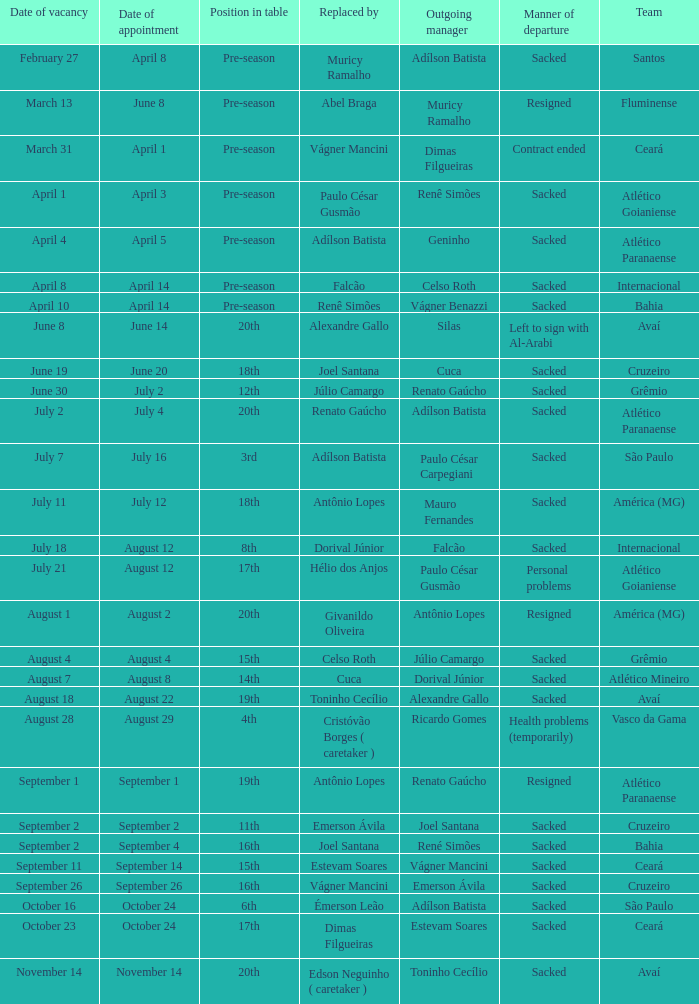Write the full table. {'header': ['Date of vacancy', 'Date of appointment', 'Position in table', 'Replaced by', 'Outgoing manager', 'Manner of departure', 'Team'], 'rows': [['February 27', 'April 8', 'Pre-season', 'Muricy Ramalho', 'Adílson Batista', 'Sacked', 'Santos'], ['March 13', 'June 8', 'Pre-season', 'Abel Braga', 'Muricy Ramalho', 'Resigned', 'Fluminense'], ['March 31', 'April 1', 'Pre-season', 'Vágner Mancini', 'Dimas Filgueiras', 'Contract ended', 'Ceará'], ['April 1', 'April 3', 'Pre-season', 'Paulo César Gusmão', 'Renê Simões', 'Sacked', 'Atlético Goianiense'], ['April 4', 'April 5', 'Pre-season', 'Adílson Batista', 'Geninho', 'Sacked', 'Atlético Paranaense'], ['April 8', 'April 14', 'Pre-season', 'Falcão', 'Celso Roth', 'Sacked', 'Internacional'], ['April 10', 'April 14', 'Pre-season', 'Renê Simões', 'Vágner Benazzi', 'Sacked', 'Bahia'], ['June 8', 'June 14', '20th', 'Alexandre Gallo', 'Silas', 'Left to sign with Al-Arabi', 'Avaí'], ['June 19', 'June 20', '18th', 'Joel Santana', 'Cuca', 'Sacked', 'Cruzeiro'], ['June 30', 'July 2', '12th', 'Júlio Camargo', 'Renato Gaúcho', 'Sacked', 'Grêmio'], ['July 2', 'July 4', '20th', 'Renato Gaúcho', 'Adílson Batista', 'Sacked', 'Atlético Paranaense'], ['July 7', 'July 16', '3rd', 'Adílson Batista', 'Paulo César Carpegiani', 'Sacked', 'São Paulo'], ['July 11', 'July 12', '18th', 'Antônio Lopes', 'Mauro Fernandes', 'Sacked', 'América (MG)'], ['July 18', 'August 12', '8th', 'Dorival Júnior', 'Falcão', 'Sacked', 'Internacional'], ['July 21', 'August 12', '17th', 'Hélio dos Anjos', 'Paulo César Gusmão', 'Personal problems', 'Atlético Goianiense'], ['August 1', 'August 2', '20th', 'Givanildo Oliveira', 'Antônio Lopes', 'Resigned', 'América (MG)'], ['August 4', 'August 4', '15th', 'Celso Roth', 'Júlio Camargo', 'Sacked', 'Grêmio'], ['August 7', 'August 8', '14th', 'Cuca', 'Dorival Júnior', 'Sacked', 'Atlético Mineiro'], ['August 18', 'August 22', '19th', 'Toninho Cecílio', 'Alexandre Gallo', 'Sacked', 'Avaí'], ['August 28', 'August 29', '4th', 'Cristóvão Borges ( caretaker )', 'Ricardo Gomes', 'Health problems (temporarily)', 'Vasco da Gama'], ['September 1', 'September 1', '19th', 'Antônio Lopes', 'Renato Gaúcho', 'Resigned', 'Atlético Paranaense'], ['September 2', 'September 2', '11th', 'Emerson Ávila', 'Joel Santana', 'Sacked', 'Cruzeiro'], ['September 2', 'September 4', '16th', 'Joel Santana', 'René Simões', 'Sacked', 'Bahia'], ['September 11', 'September 14', '15th', 'Estevam Soares', 'Vágner Mancini', 'Sacked', 'Ceará'], ['September 26', 'September 26', '16th', 'Vágner Mancini', 'Emerson Ávila', 'Sacked', 'Cruzeiro'], ['October 16', 'October 24', '6th', 'Émerson Leão', 'Adílson Batista', 'Sacked', 'São Paulo'], ['October 23', 'October 24', '17th', 'Dimas Filgueiras', 'Estevam Soares', 'Sacked', 'Ceará'], ['November 14', 'November 14', '20th', 'Edson Neguinho ( caretaker )', 'Toninho Cecílio', 'Sacked', 'Avaí']]} What team hired Renato Gaúcho? Atlético Paranaense. 